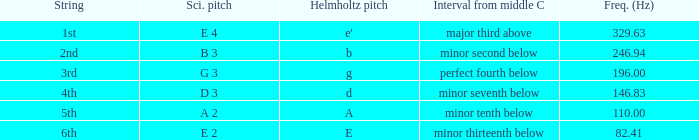What is the lowest Frequency where the Hemholtz pitch is d? 146.83. 